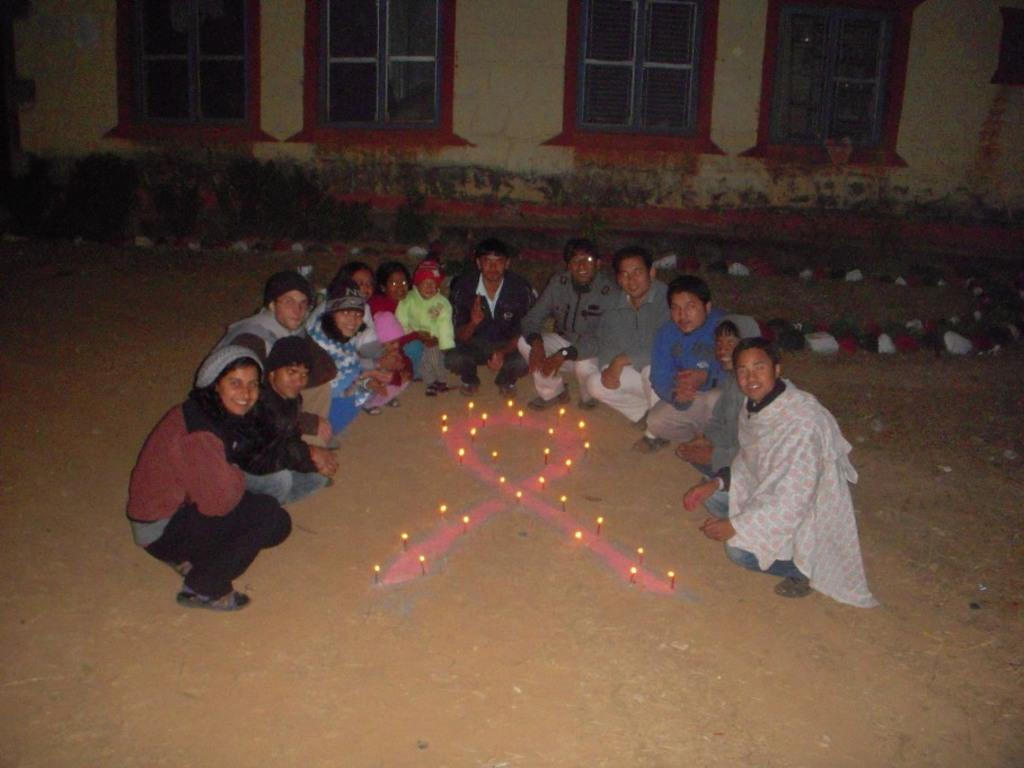What are the people in the image doing? There is a group of persons crouching down on the ground in the image. What objects can be seen on the ground with the people? There are candles on the ground in the image. What can be seen in the background of the image? There is a house and plants in the background of the image. What type of friction can be seen between the candles and the ground in the image? There is no mention of friction in the image, as it focuses on the people crouching down and the presence of candles on the ground. --- Facts: 1. There is a person holding a camera in the image. 2. The person is standing on a bridge. 3. There is a river below the bridge. 4. There are trees on both sides of the river. Absurd Topics: elephant, piano Conversation: What is the person in the image doing? The person in the image is holding a camera. Where is the person standing? The person is standing on a bridge. What can be seen below the bridge? There is a river below the bridge. What is present on both sides of the river? There are trees on both sides of the river. Reasoning: Let's think step by step in order to ${produce the conversation}. We start by identifying the main subject of the image, which is the person holding a camera. Next, we describe the person's location, which is on a bridge. Then, we observe the surroundings, noting the presence of a river below the bridge and trees on both sides of the river. Absurd Question/Answer: What type of elephant can be seen playing a piano in the image? There is no elephant or piano present in the image. 